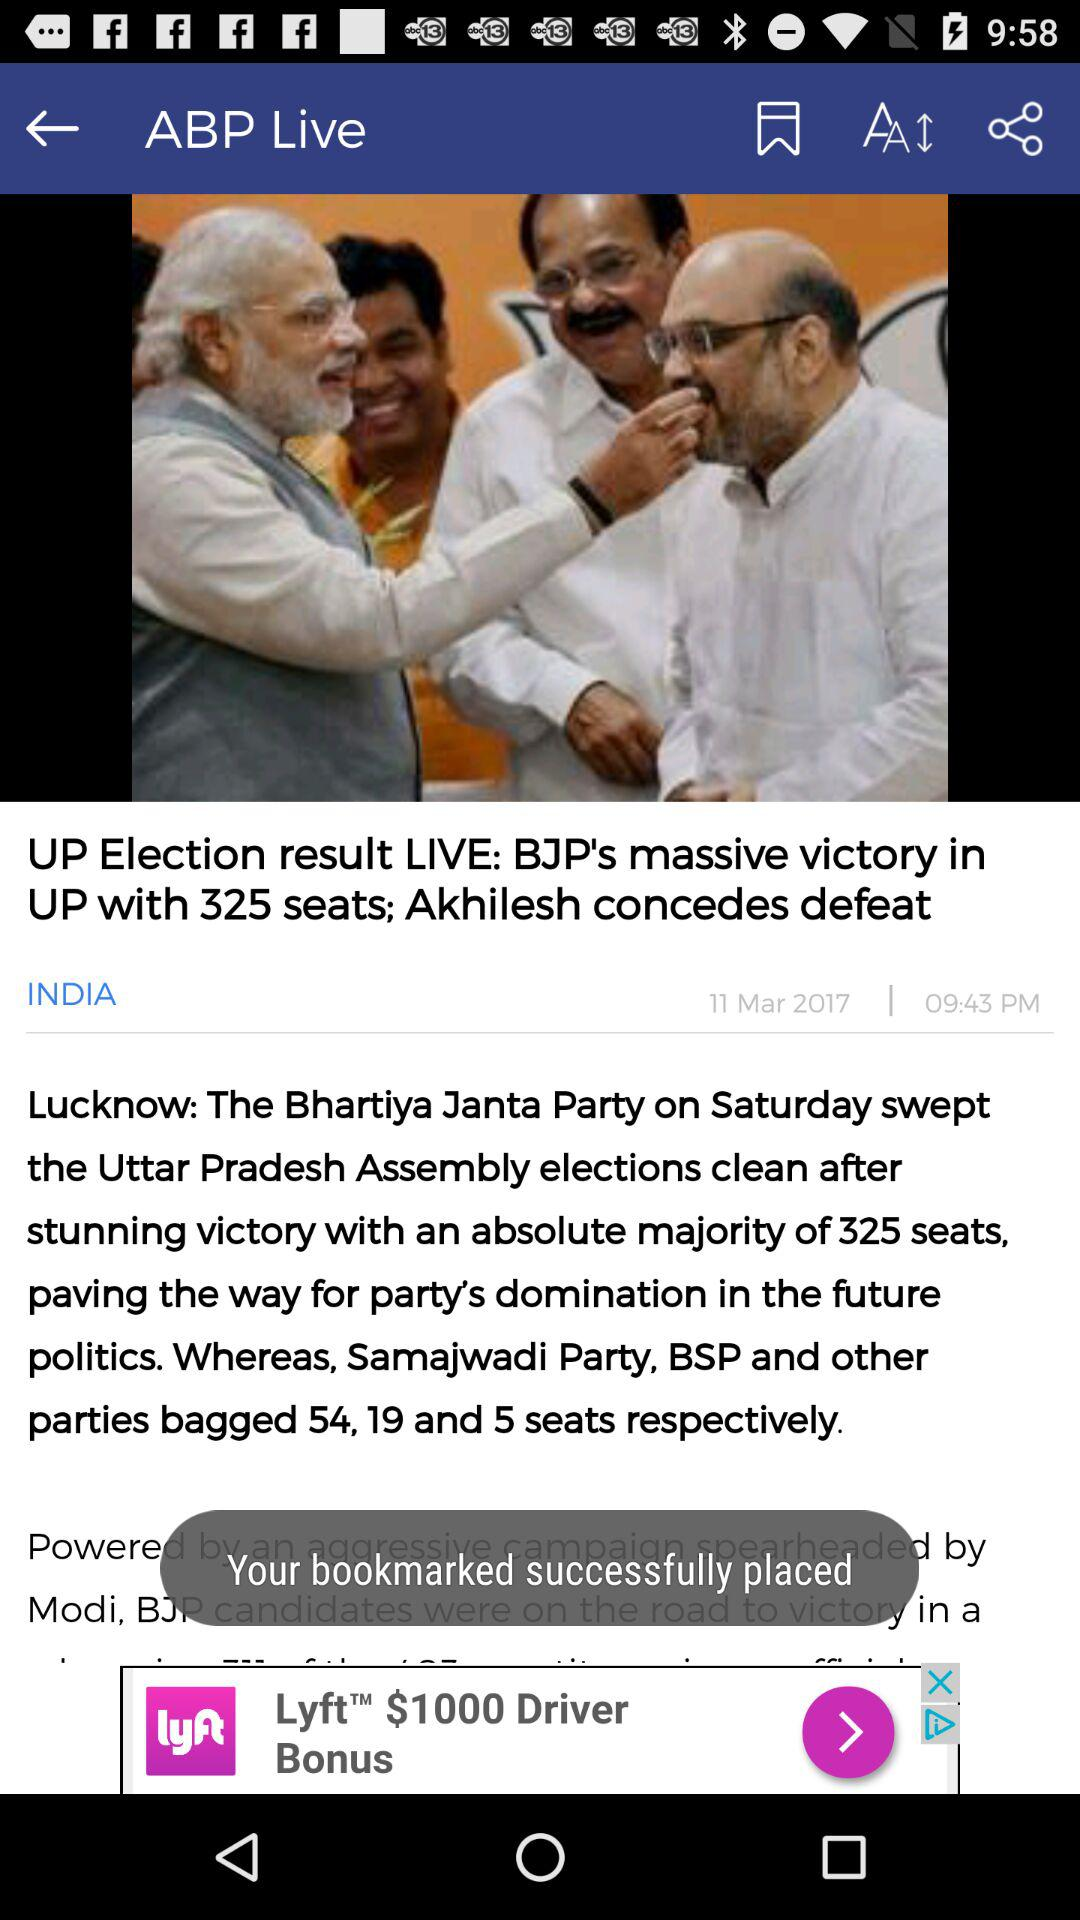Where did the news coverage happen? The news coverage happened in Lucknow. 